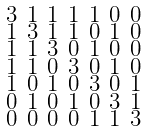Convert formula to latex. <formula><loc_0><loc_0><loc_500><loc_500>\begin{smallmatrix} 3 & 1 & 1 & 1 & 1 & 0 & 0 \\ 1 & 3 & 1 & 1 & 0 & 1 & 0 \\ 1 & 1 & 3 & 0 & 1 & 0 & 0 \\ 1 & 1 & 0 & 3 & 0 & 1 & 0 \\ 1 & 0 & 1 & 0 & 3 & 0 & 1 \\ 0 & 1 & 0 & 1 & 0 & 3 & 1 \\ 0 & 0 & 0 & 0 & 1 & 1 & 3 \end{smallmatrix}</formula> 